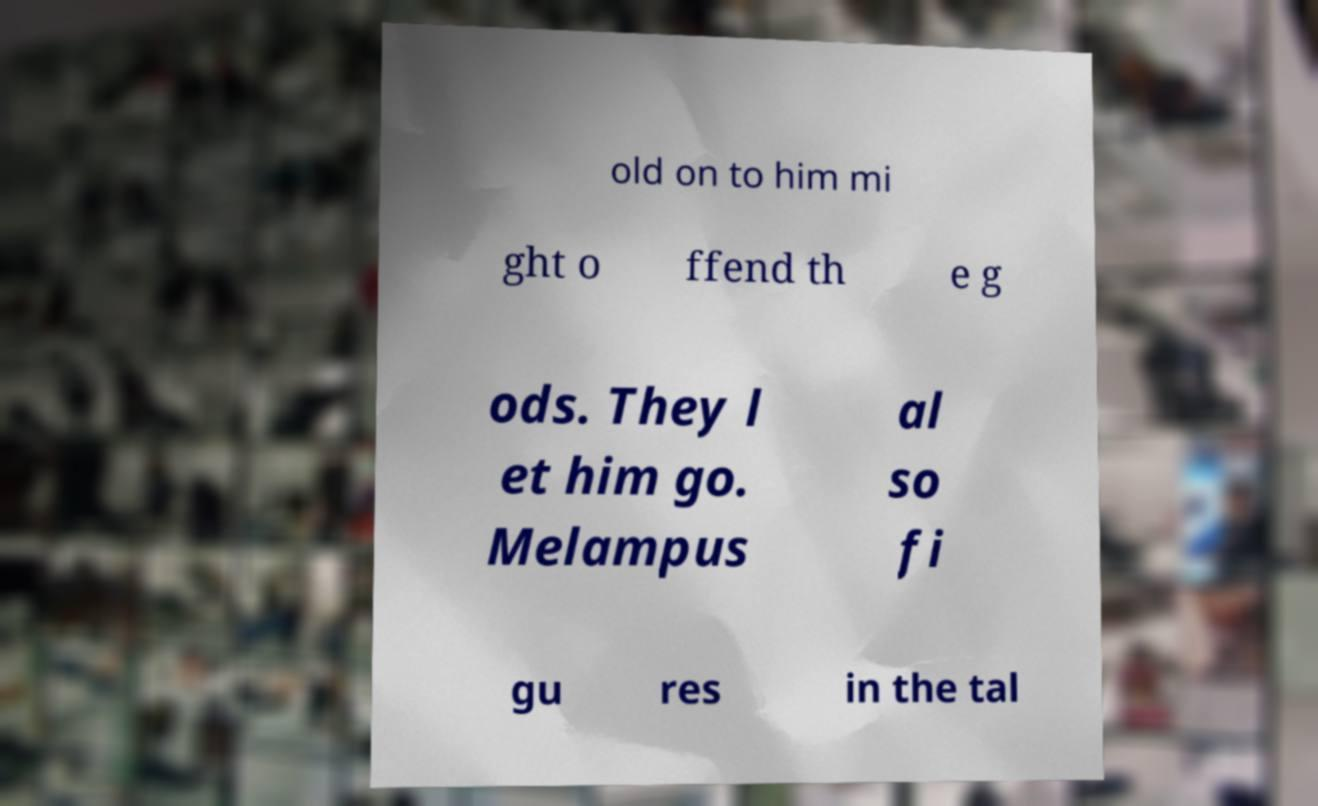There's text embedded in this image that I need extracted. Can you transcribe it verbatim? old on to him mi ght o ffend th e g ods. They l et him go. Melampus al so fi gu res in the tal 